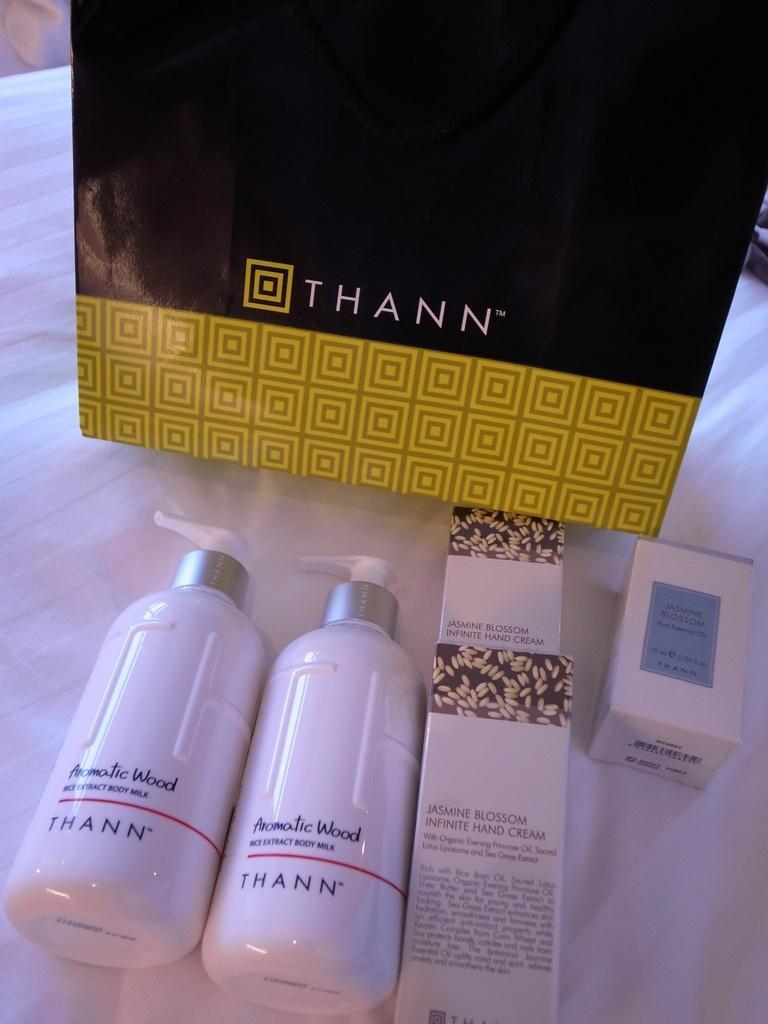How would you summarize this image in a sentence or two? In this image i can see two bottles and a cover on the bed. 